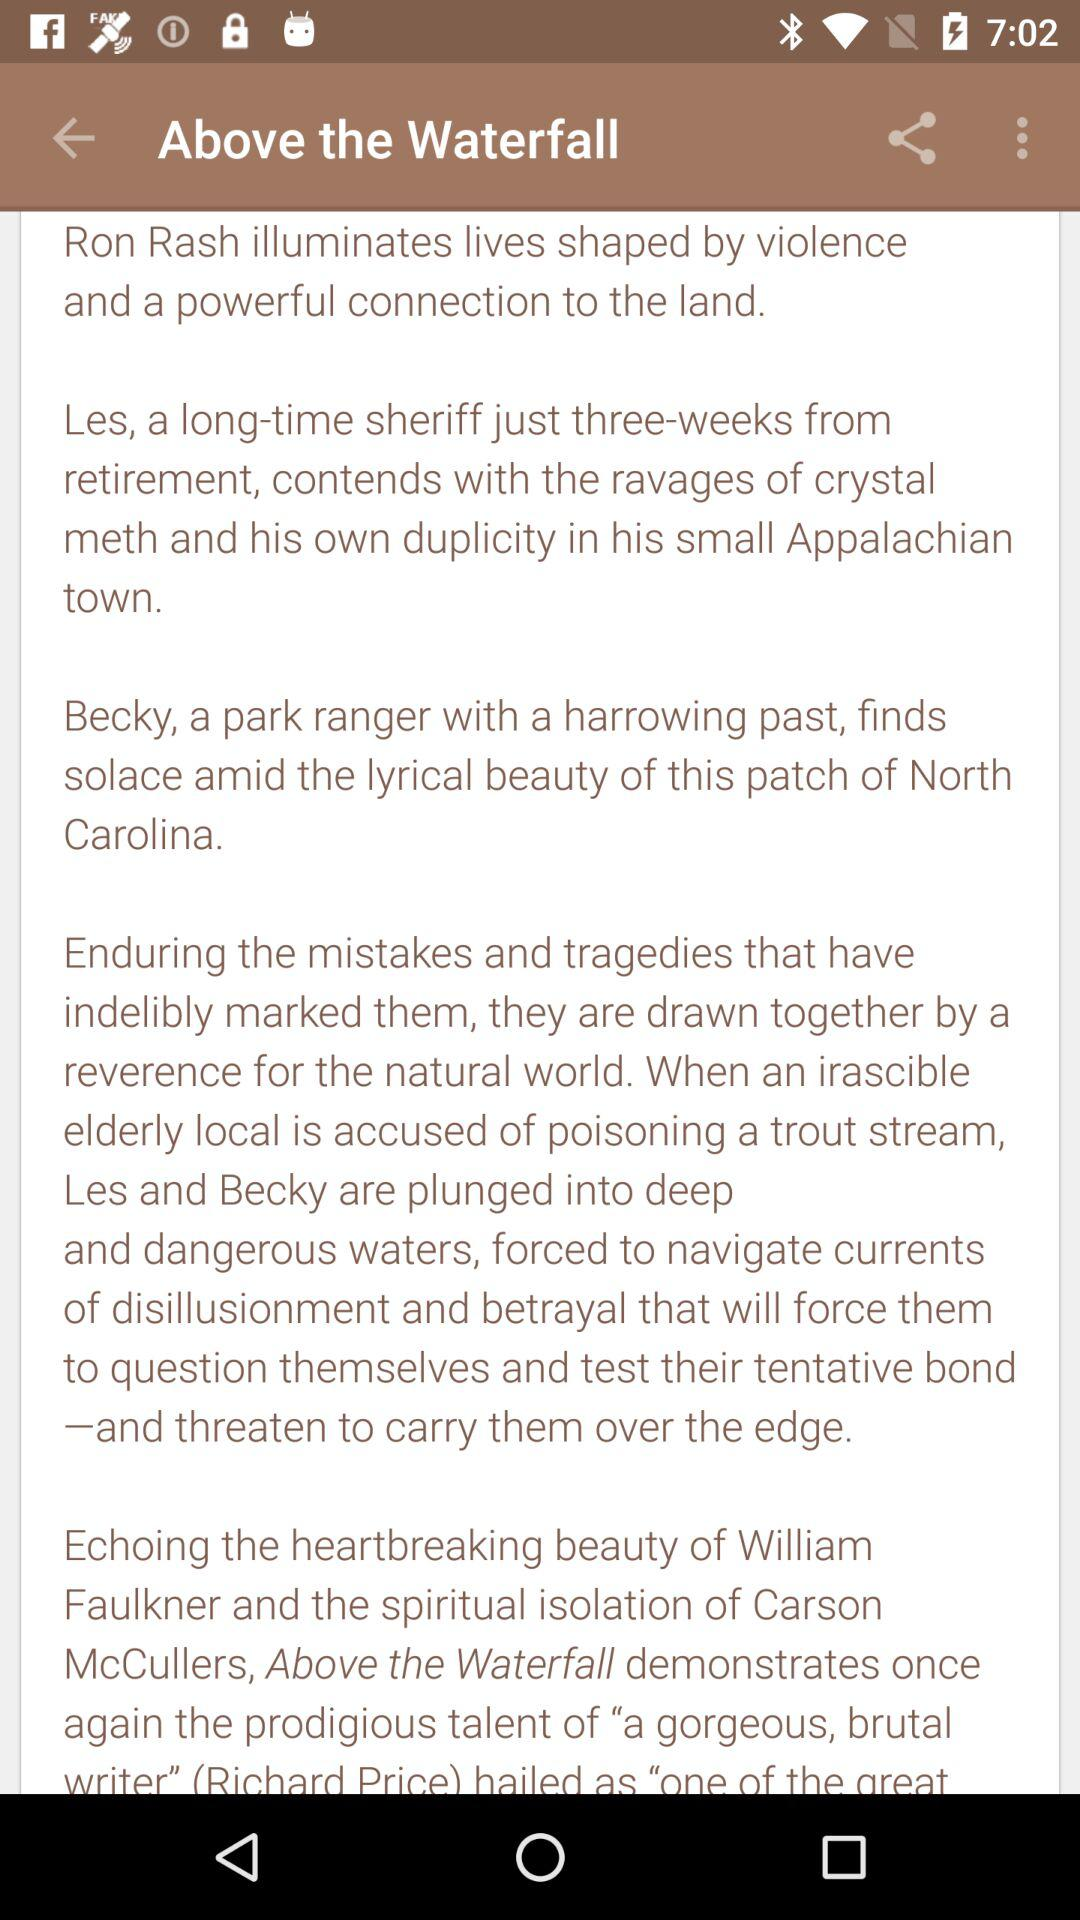How many lines of text are there about the book?
Answer the question using a single word or phrase. 5 